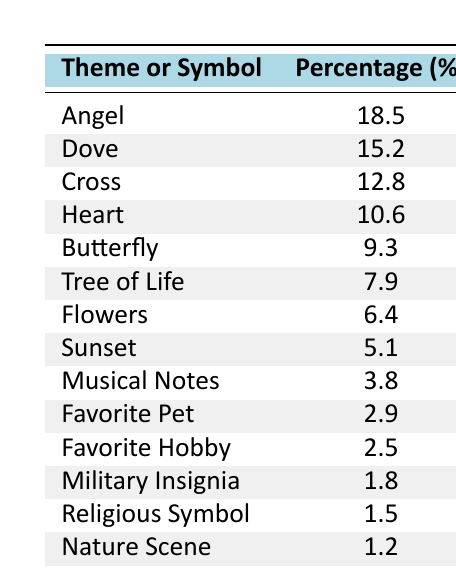What is the most requested theme or symbol in memorial artwork? The table lists various themes or symbols along with their corresponding percentages. The highest percentage is 18.5, which corresponds to the "Angel" theme.
Answer: Angel What is the percentage of requests for flowers? The table shows that the percentage for "Flowers" is 6.4%.
Answer: 6.4% How many themes or symbols have a percentage greater than 10%? We can count the entries in the table with percentages over 10%. These themes are Angel (18.5), Dove (15.2), Cross (12.8), and Heart (10.6), totaling four themes.
Answer: 4 What is the difference in percentage between the themes "Dove" and "Butterfly"? The percentage for "Dove" is 15.2% and for "Butterfly," it is 9.3%. The difference is 15.2 - 9.3 = 5.9%.
Answer: 5.9% Is the percentage for "Portrait" higher than that for "Nature Scene"? The percentage for "Portrait" is 0.5%, and for "Nature Scene," it is 1.2%. Since 0.5% is less than 1.2%, the statement is false.
Answer: No What percentage of the themes requested is accounted for by the top three themes combined? The top three themes are Angel (18.5%), Dove (15.2%), and Cross (12.8%). Summing these gives 18.5 + 15.2 + 12.8 = 46.5%.
Answer: 46.5% Which theme has the least percentage of requests and what is that percentage? Referring to the table, the theme with the least percentage is "Portrait" at 0.5%.
Answer: Portrait, 0.5% What is the average percentage of the themes that include animal symbols? The animal symbols in the table are "Dove," "Butterfly," and "Favorite Pet." Their percentages are 15.2%, 9.3%, and 2.9%. To find the average, sum these percentages: 15.2 + 9.3 + 2.9 = 27.4% and divide by 3, yielding an average of 9.13%.
Answer: 9.13% Are there more themes that are nature-related (like "Dove" and "Tree of Life") than those that are artistic (like "Musical Notes" and "Portrait")? The nature-related themes include "Dove," "Tree of Life," and "Nature Scene," totaling three themes. The artistic themes include "Musical Notes" and "Portrait," totaling two. Since 3 is greater than 2, the answer is yes.
Answer: Yes 